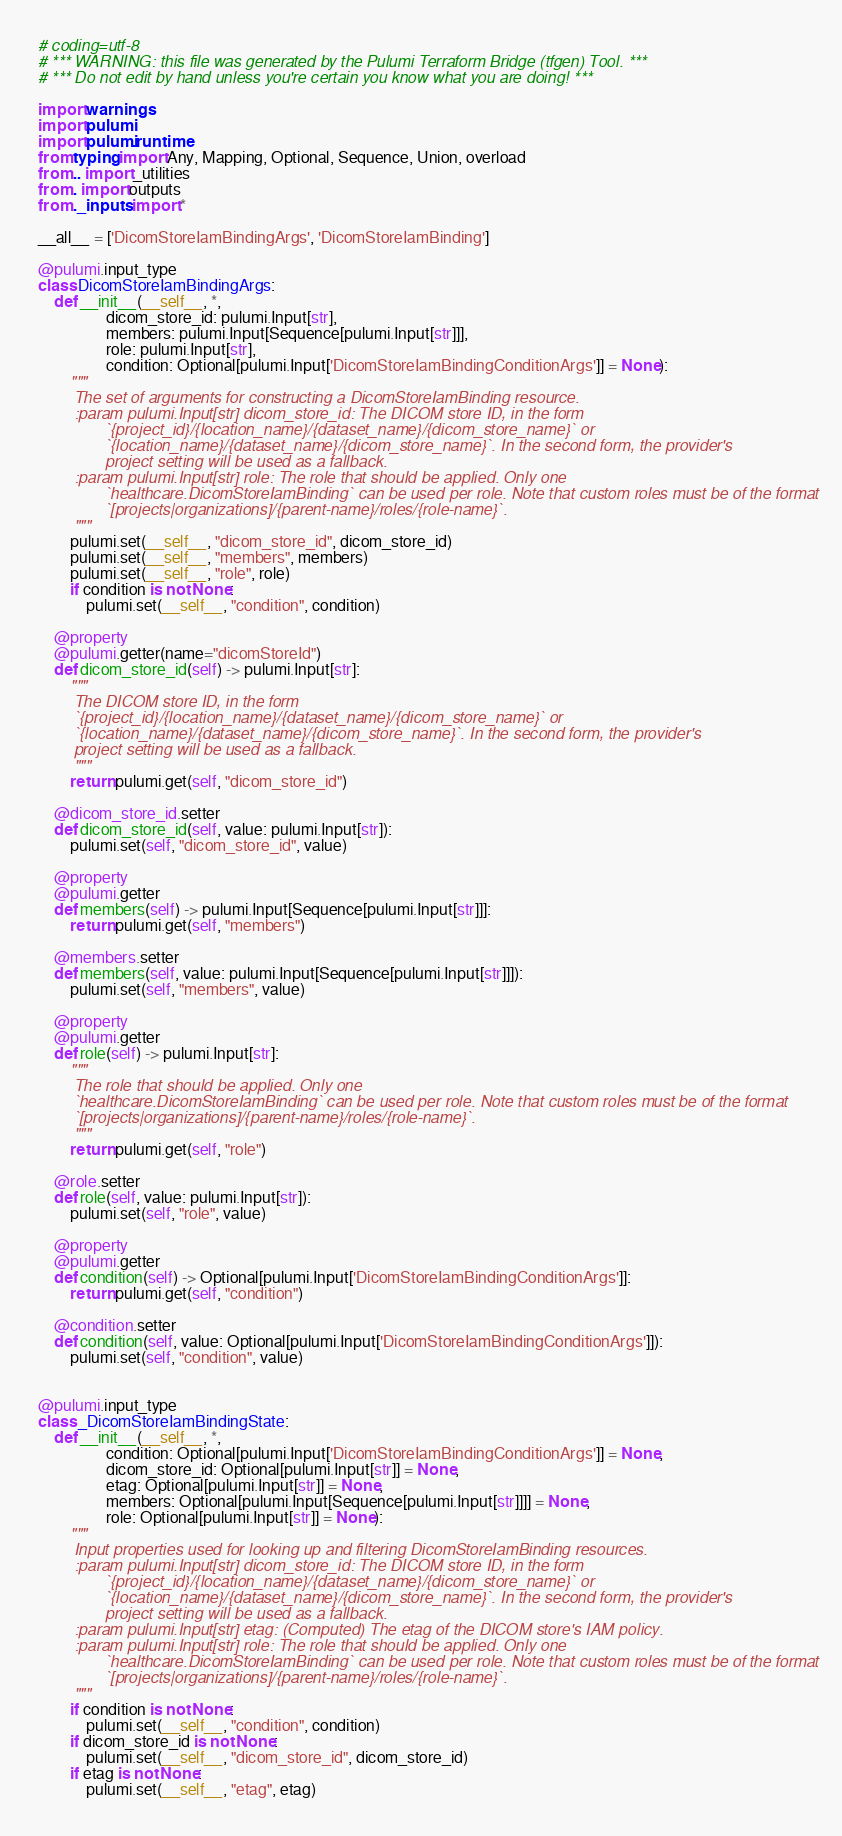Convert code to text. <code><loc_0><loc_0><loc_500><loc_500><_Python_># coding=utf-8
# *** WARNING: this file was generated by the Pulumi Terraform Bridge (tfgen) Tool. ***
# *** Do not edit by hand unless you're certain you know what you are doing! ***

import warnings
import pulumi
import pulumi.runtime
from typing import Any, Mapping, Optional, Sequence, Union, overload
from .. import _utilities
from . import outputs
from ._inputs import *

__all__ = ['DicomStoreIamBindingArgs', 'DicomStoreIamBinding']

@pulumi.input_type
class DicomStoreIamBindingArgs:
    def __init__(__self__, *,
                 dicom_store_id: pulumi.Input[str],
                 members: pulumi.Input[Sequence[pulumi.Input[str]]],
                 role: pulumi.Input[str],
                 condition: Optional[pulumi.Input['DicomStoreIamBindingConditionArgs']] = None):
        """
        The set of arguments for constructing a DicomStoreIamBinding resource.
        :param pulumi.Input[str] dicom_store_id: The DICOM store ID, in the form
               `{project_id}/{location_name}/{dataset_name}/{dicom_store_name}` or
               `{location_name}/{dataset_name}/{dicom_store_name}`. In the second form, the provider's
               project setting will be used as a fallback.
        :param pulumi.Input[str] role: The role that should be applied. Only one
               `healthcare.DicomStoreIamBinding` can be used per role. Note that custom roles must be of the format
               `[projects|organizations]/{parent-name}/roles/{role-name}`.
        """
        pulumi.set(__self__, "dicom_store_id", dicom_store_id)
        pulumi.set(__self__, "members", members)
        pulumi.set(__self__, "role", role)
        if condition is not None:
            pulumi.set(__self__, "condition", condition)

    @property
    @pulumi.getter(name="dicomStoreId")
    def dicom_store_id(self) -> pulumi.Input[str]:
        """
        The DICOM store ID, in the form
        `{project_id}/{location_name}/{dataset_name}/{dicom_store_name}` or
        `{location_name}/{dataset_name}/{dicom_store_name}`. In the second form, the provider's
        project setting will be used as a fallback.
        """
        return pulumi.get(self, "dicom_store_id")

    @dicom_store_id.setter
    def dicom_store_id(self, value: pulumi.Input[str]):
        pulumi.set(self, "dicom_store_id", value)

    @property
    @pulumi.getter
    def members(self) -> pulumi.Input[Sequence[pulumi.Input[str]]]:
        return pulumi.get(self, "members")

    @members.setter
    def members(self, value: pulumi.Input[Sequence[pulumi.Input[str]]]):
        pulumi.set(self, "members", value)

    @property
    @pulumi.getter
    def role(self) -> pulumi.Input[str]:
        """
        The role that should be applied. Only one
        `healthcare.DicomStoreIamBinding` can be used per role. Note that custom roles must be of the format
        `[projects|organizations]/{parent-name}/roles/{role-name}`.
        """
        return pulumi.get(self, "role")

    @role.setter
    def role(self, value: pulumi.Input[str]):
        pulumi.set(self, "role", value)

    @property
    @pulumi.getter
    def condition(self) -> Optional[pulumi.Input['DicomStoreIamBindingConditionArgs']]:
        return pulumi.get(self, "condition")

    @condition.setter
    def condition(self, value: Optional[pulumi.Input['DicomStoreIamBindingConditionArgs']]):
        pulumi.set(self, "condition", value)


@pulumi.input_type
class _DicomStoreIamBindingState:
    def __init__(__self__, *,
                 condition: Optional[pulumi.Input['DicomStoreIamBindingConditionArgs']] = None,
                 dicom_store_id: Optional[pulumi.Input[str]] = None,
                 etag: Optional[pulumi.Input[str]] = None,
                 members: Optional[pulumi.Input[Sequence[pulumi.Input[str]]]] = None,
                 role: Optional[pulumi.Input[str]] = None):
        """
        Input properties used for looking up and filtering DicomStoreIamBinding resources.
        :param pulumi.Input[str] dicom_store_id: The DICOM store ID, in the form
               `{project_id}/{location_name}/{dataset_name}/{dicom_store_name}` or
               `{location_name}/{dataset_name}/{dicom_store_name}`. In the second form, the provider's
               project setting will be used as a fallback.
        :param pulumi.Input[str] etag: (Computed) The etag of the DICOM store's IAM policy.
        :param pulumi.Input[str] role: The role that should be applied. Only one
               `healthcare.DicomStoreIamBinding` can be used per role. Note that custom roles must be of the format
               `[projects|organizations]/{parent-name}/roles/{role-name}`.
        """
        if condition is not None:
            pulumi.set(__self__, "condition", condition)
        if dicom_store_id is not None:
            pulumi.set(__self__, "dicom_store_id", dicom_store_id)
        if etag is not None:
            pulumi.set(__self__, "etag", etag)</code> 